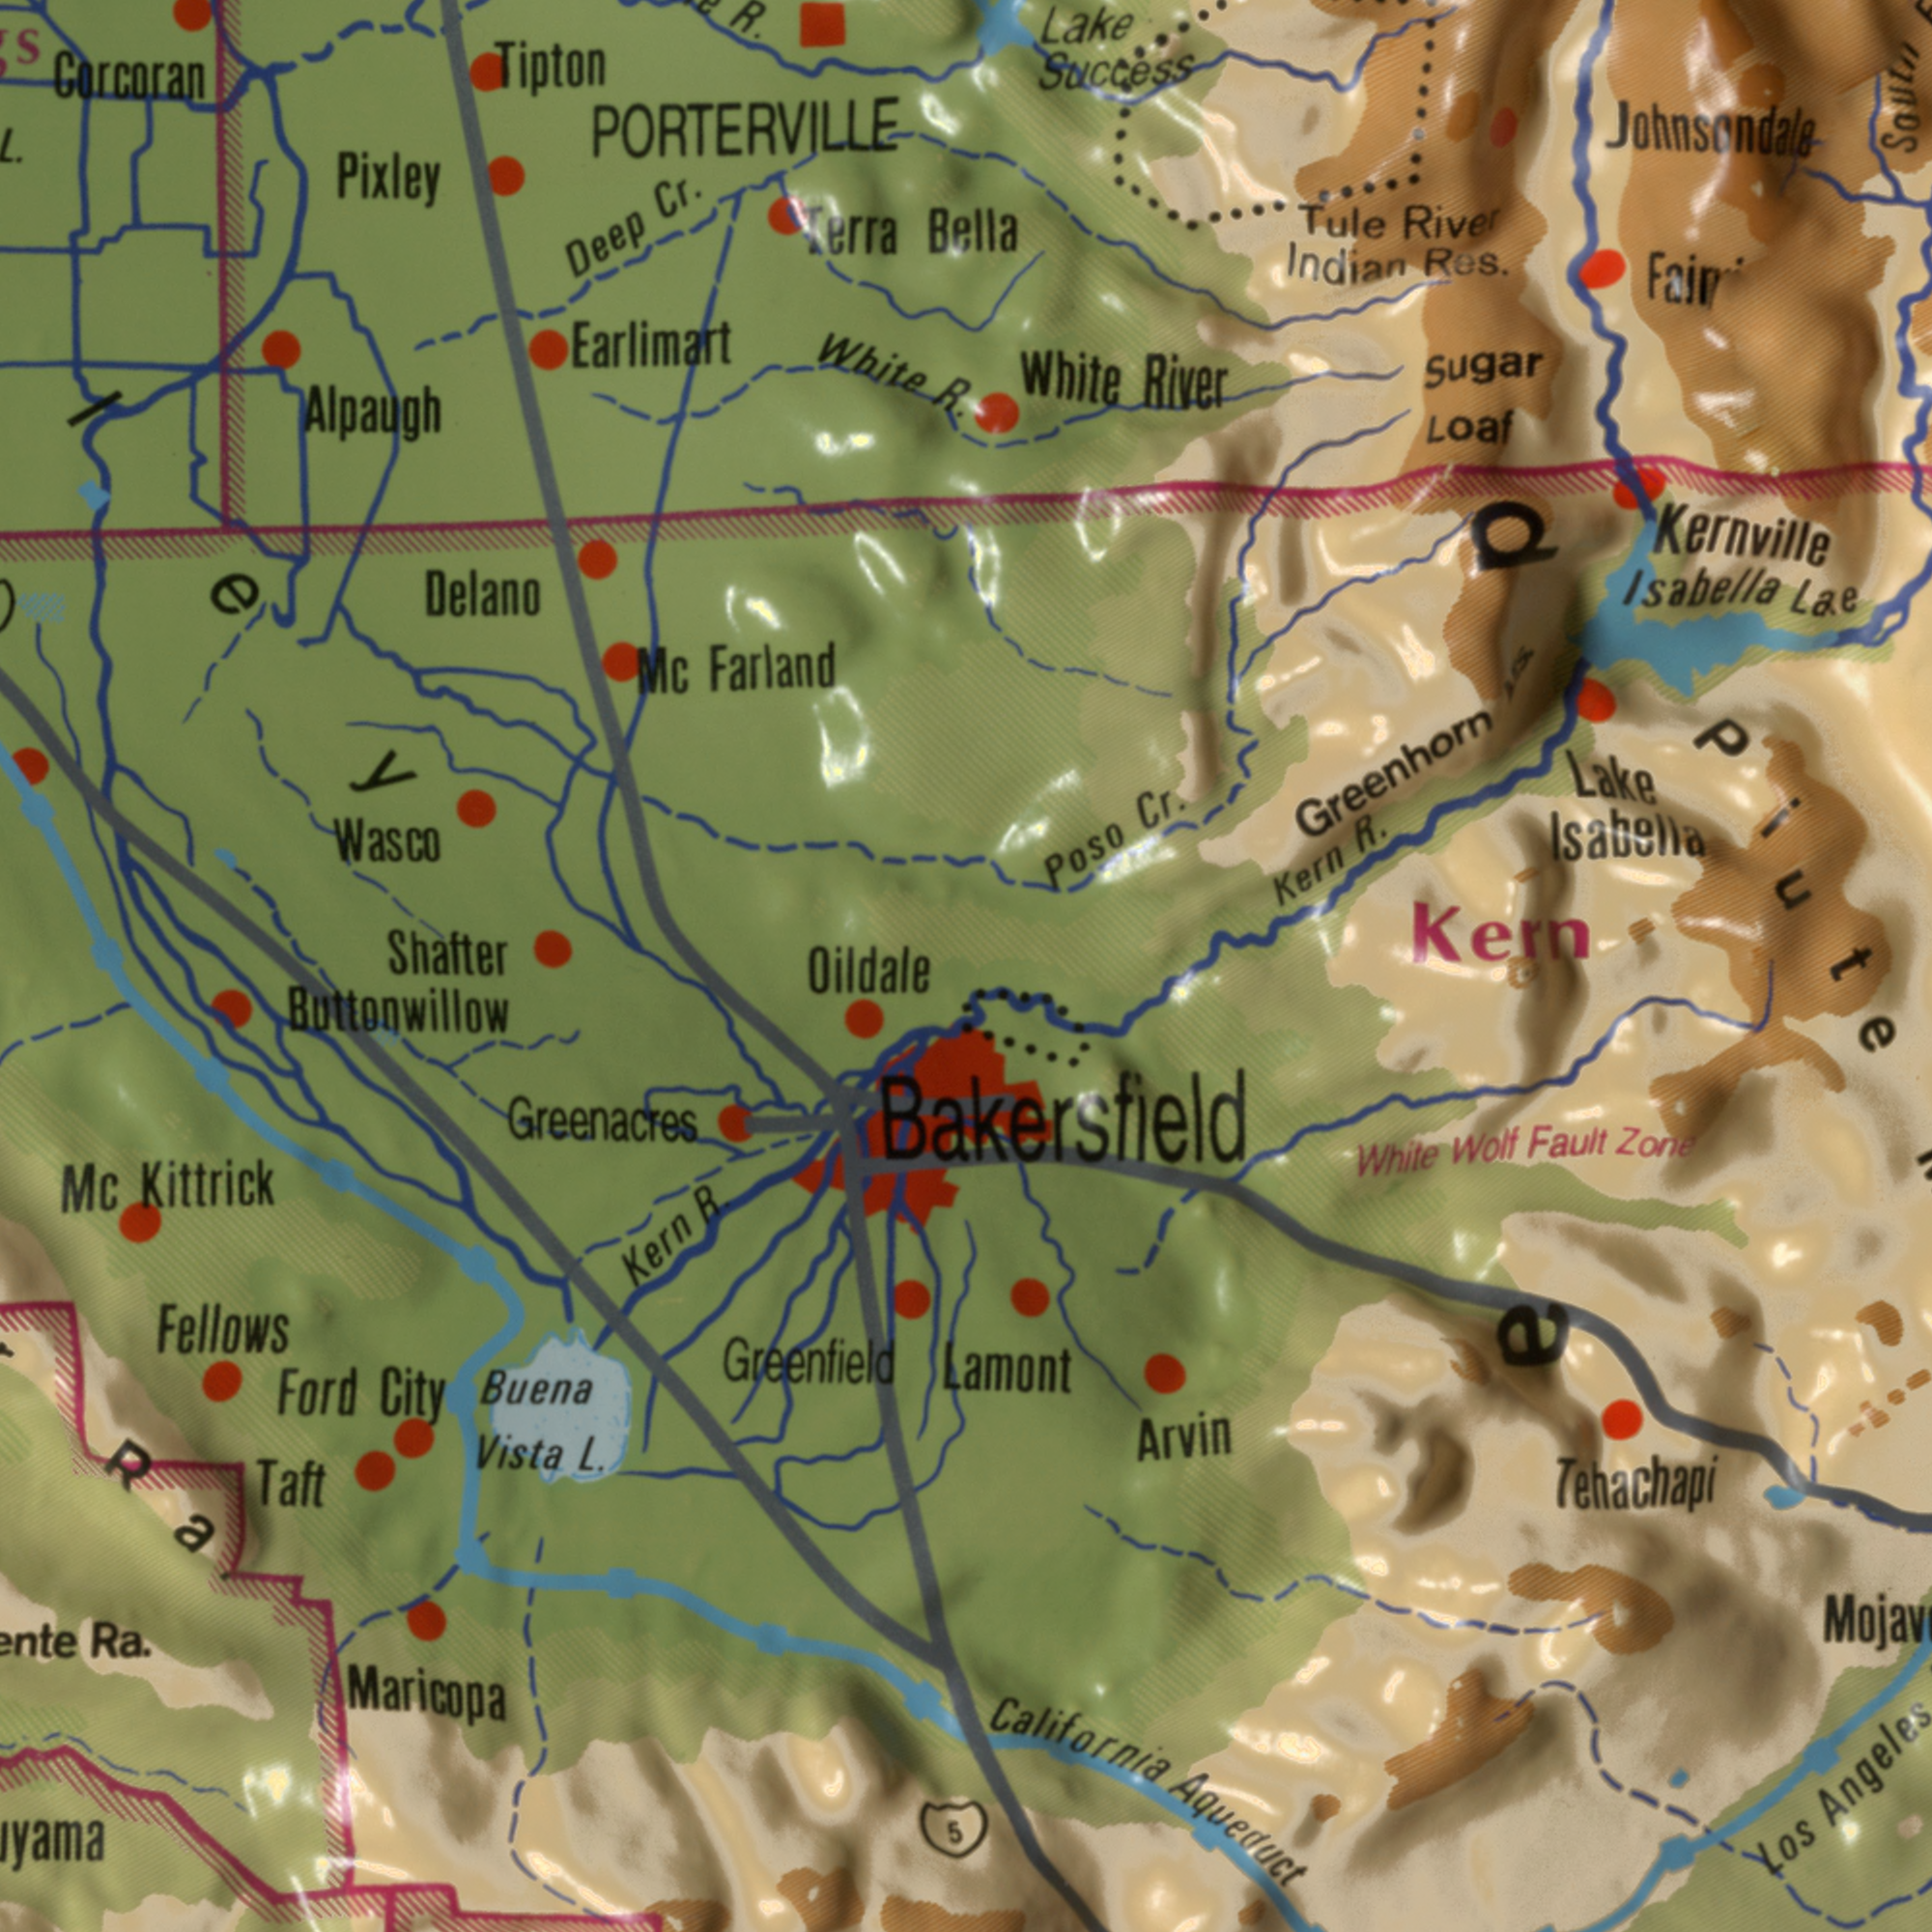What text is visible in the lower-left corner? Shafter Maricopa Buena Fellows Mc L. R. Kittrick Vista Taft Ford Greenfield Gity Kern 5 Ra. Buttonwillow Greenacres Oildale Ra What text appears in the top-right area of the image? Isabella Lake White Greenhorn Kern Indian Success Lake Isabella Res. Cr. Poso River R. Sugar Fair Kern Tule Kernville Loaf South Lake River Johnsondals Bella Piute ep What text is shown in the top-left quadrant? Gorcoran PORTERVILLE Pixley Alpaugh Earlimart White Farland Cr. Deep Wasco Delano R. Mc Tipton L. Terra R. ###ley What text appears in the bottom-right area of the image? Aqueduct California Tehachapi Angeles White Wolf Arvin Fault Los Zone Bakersfield Lamont 